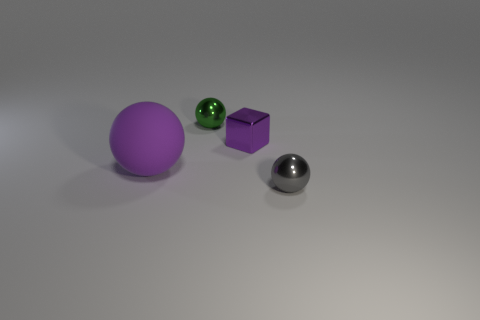Is the number of large purple spheres less than the number of small objects?
Keep it short and to the point. Yes. How many metal things have the same shape as the matte thing?
Your answer should be very brief. 2. What number of gray things are either metal balls or tiny cylinders?
Offer a very short reply. 1. There is a metallic ball behind the thing that is in front of the big purple thing; what size is it?
Your answer should be very brief. Small. What material is the other tiny gray thing that is the same shape as the matte thing?
Provide a succinct answer. Metal. What number of purple shiny blocks have the same size as the green shiny ball?
Your response must be concise. 1. Is the purple matte ball the same size as the gray shiny sphere?
Ensure brevity in your answer.  No. There is a ball that is to the right of the large matte ball and left of the purple metallic block; what size is it?
Your answer should be compact. Small. Are there more gray metal things to the right of the small green metallic thing than tiny green things to the right of the small gray thing?
Give a very brief answer. Yes. The large object that is the same shape as the small green object is what color?
Offer a terse response. Purple. 